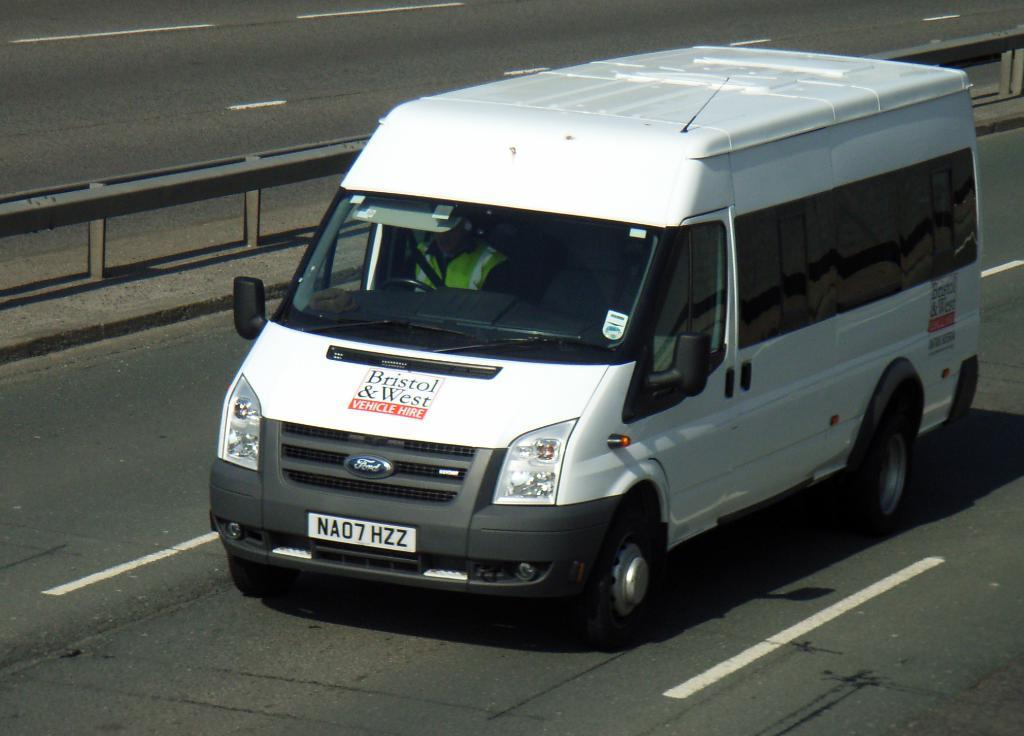<image>
Offer a succinct explanation of the picture presented. A white Bristol & West van that can be hired is travelling down the freeway. 